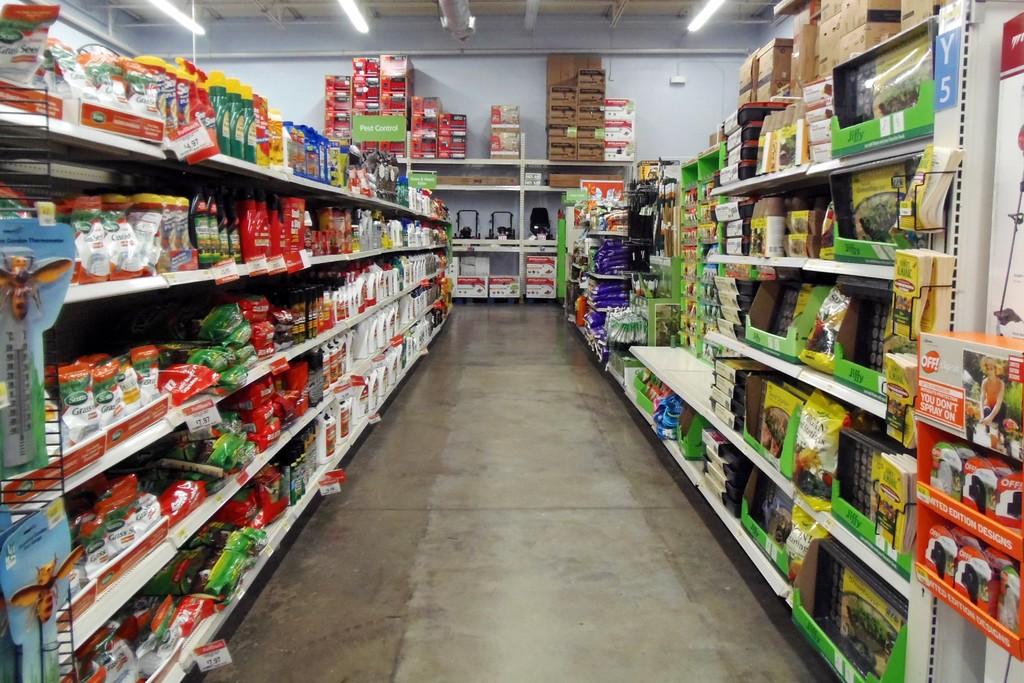What brand of bug spray is closest?
Ensure brevity in your answer.  Off. 